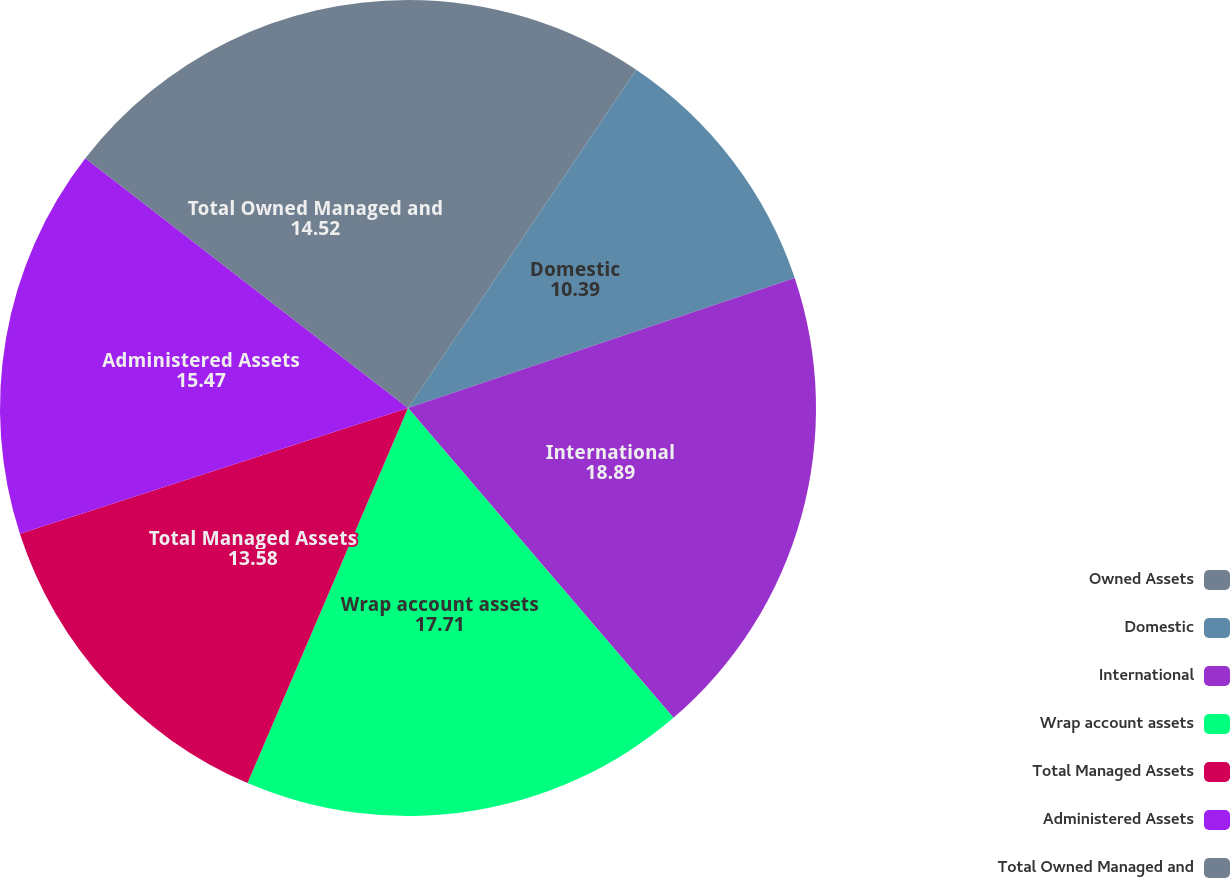<chart> <loc_0><loc_0><loc_500><loc_500><pie_chart><fcel>Owned Assets<fcel>Domestic<fcel>International<fcel>Wrap account assets<fcel>Total Managed Assets<fcel>Administered Assets<fcel>Total Owned Managed and<nl><fcel>9.45%<fcel>10.39%<fcel>18.89%<fcel>17.71%<fcel>13.58%<fcel>15.47%<fcel>14.52%<nl></chart> 